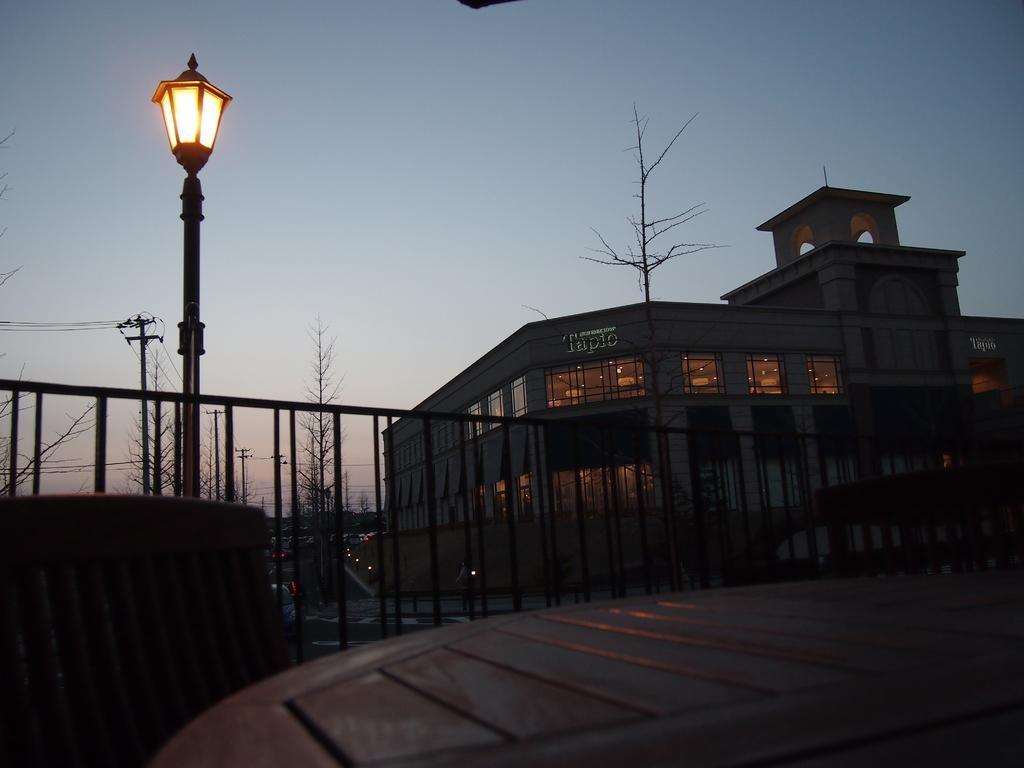Could you give a brief overview of what you see in this image? In this image I can see a light pole, railing, a building, a current pole, few dried trees and the sky is in white and blue color. 